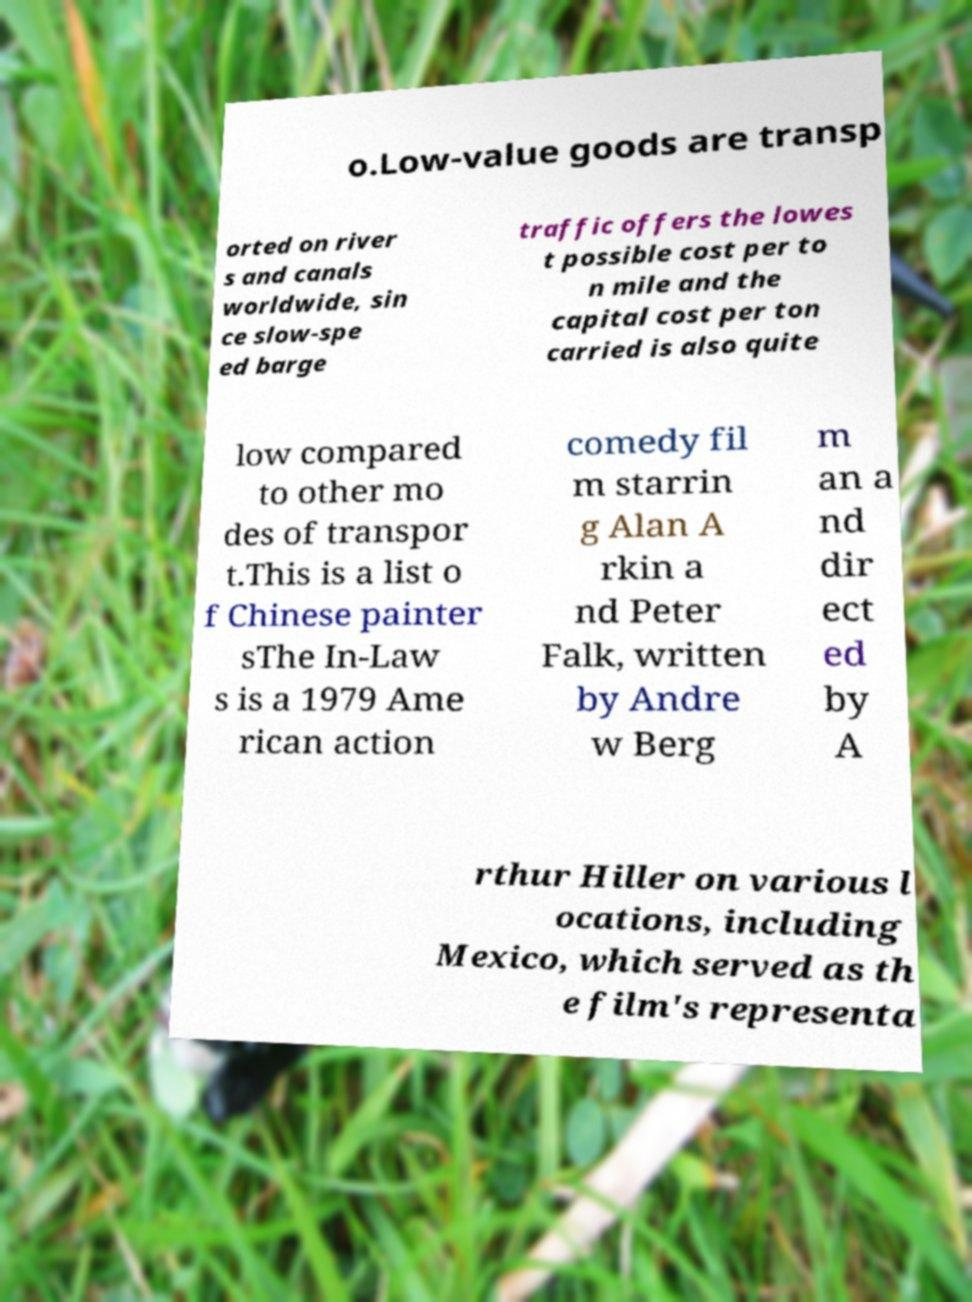For documentation purposes, I need the text within this image transcribed. Could you provide that? o.Low-value goods are transp orted on river s and canals worldwide, sin ce slow-spe ed barge traffic offers the lowes t possible cost per to n mile and the capital cost per ton carried is also quite low compared to other mo des of transpor t.This is a list o f Chinese painter sThe In-Law s is a 1979 Ame rican action comedy fil m starrin g Alan A rkin a nd Peter Falk, written by Andre w Berg m an a nd dir ect ed by A rthur Hiller on various l ocations, including Mexico, which served as th e film's representa 